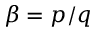<formula> <loc_0><loc_0><loc_500><loc_500>\beta = p / q</formula> 